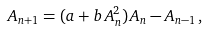Convert formula to latex. <formula><loc_0><loc_0><loc_500><loc_500>A _ { n + 1 } = ( a + b \, A _ { n } ^ { 2 } ) \, A _ { n } - A _ { n - 1 } \, ,</formula> 